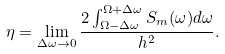<formula> <loc_0><loc_0><loc_500><loc_500>\eta = \lim _ { \Delta \omega \rightarrow 0 } \frac { 2 \int ^ { \Omega + \Delta \omega } _ { \Omega - \Delta \omega } S _ { m } ( \omega ) d \omega } { h ^ { 2 } } .</formula> 